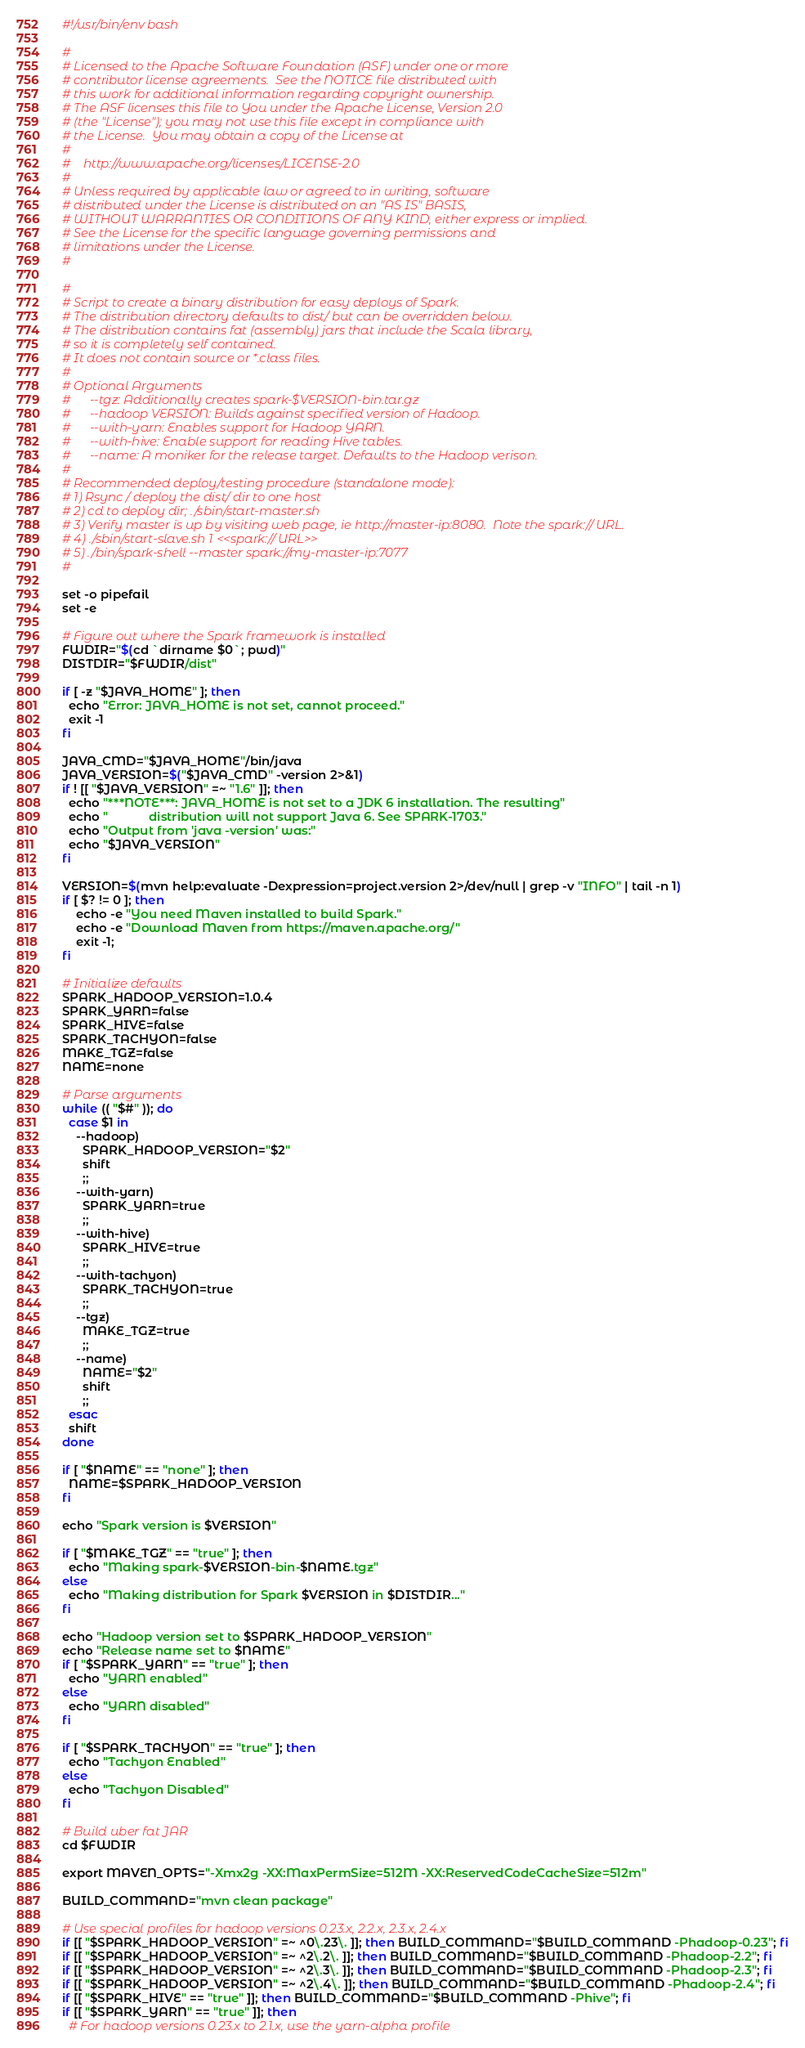<code> <loc_0><loc_0><loc_500><loc_500><_Bash_>#!/usr/bin/env bash

#
# Licensed to the Apache Software Foundation (ASF) under one or more
# contributor license agreements.  See the NOTICE file distributed with
# this work for additional information regarding copyright ownership.
# The ASF licenses this file to You under the Apache License, Version 2.0
# (the "License"); you may not use this file except in compliance with
# the License.  You may obtain a copy of the License at
#
#    http://www.apache.org/licenses/LICENSE-2.0
#
# Unless required by applicable law or agreed to in writing, software
# distributed under the License is distributed on an "AS IS" BASIS,
# WITHOUT WARRANTIES OR CONDITIONS OF ANY KIND, either express or implied.
# See the License for the specific language governing permissions and
# limitations under the License.
#

#
# Script to create a binary distribution for easy deploys of Spark.
# The distribution directory defaults to dist/ but can be overridden below.
# The distribution contains fat (assembly) jars that include the Scala library,
# so it is completely self contained.
# It does not contain source or *.class files.
#
# Optional Arguments
#      --tgz: Additionally creates spark-$VERSION-bin.tar.gz
#      --hadoop VERSION: Builds against specified version of Hadoop.
#      --with-yarn: Enables support for Hadoop YARN.
#      --with-hive: Enable support for reading Hive tables.
#      --name: A moniker for the release target. Defaults to the Hadoop verison.
#
# Recommended deploy/testing procedure (standalone mode):
# 1) Rsync / deploy the dist/ dir to one host
# 2) cd to deploy dir; ./sbin/start-master.sh
# 3) Verify master is up by visiting web page, ie http://master-ip:8080.  Note the spark:// URL.
# 4) ./sbin/start-slave.sh 1 <<spark:// URL>>
# 5) ./bin/spark-shell --master spark://my-master-ip:7077
#

set -o pipefail
set -e

# Figure out where the Spark framework is installed
FWDIR="$(cd `dirname $0`; pwd)"
DISTDIR="$FWDIR/dist"

if [ -z "$JAVA_HOME" ]; then
  echo "Error: JAVA_HOME is not set, cannot proceed."
  exit -1
fi

JAVA_CMD="$JAVA_HOME"/bin/java
JAVA_VERSION=$("$JAVA_CMD" -version 2>&1)
if ! [[ "$JAVA_VERSION" =~ "1.6" ]]; then
  echo "***NOTE***: JAVA_HOME is not set to a JDK 6 installation. The resulting"
  echo "            distribution will not support Java 6. See SPARK-1703."
  echo "Output from 'java -version' was:"
  echo "$JAVA_VERSION"
fi

VERSION=$(mvn help:evaluate -Dexpression=project.version 2>/dev/null | grep -v "INFO" | tail -n 1)
if [ $? != 0 ]; then
    echo -e "You need Maven installed to build Spark."
    echo -e "Download Maven from https://maven.apache.org/"
    exit -1;
fi

# Initialize defaults
SPARK_HADOOP_VERSION=1.0.4
SPARK_YARN=false
SPARK_HIVE=false
SPARK_TACHYON=false
MAKE_TGZ=false
NAME=none

# Parse arguments
while (( "$#" )); do
  case $1 in
    --hadoop)
      SPARK_HADOOP_VERSION="$2"
      shift
      ;;
    --with-yarn)
      SPARK_YARN=true
      ;;
    --with-hive)
      SPARK_HIVE=true
      ;;
    --with-tachyon)
      SPARK_TACHYON=true
      ;;
    --tgz)
      MAKE_TGZ=true
      ;;
    --name)
      NAME="$2"
      shift
      ;;
  esac
  shift
done

if [ "$NAME" == "none" ]; then
  NAME=$SPARK_HADOOP_VERSION
fi

echo "Spark version is $VERSION"

if [ "$MAKE_TGZ" == "true" ]; then
  echo "Making spark-$VERSION-bin-$NAME.tgz"
else
  echo "Making distribution for Spark $VERSION in $DISTDIR..."
fi

echo "Hadoop version set to $SPARK_HADOOP_VERSION"
echo "Release name set to $NAME"
if [ "$SPARK_YARN" == "true" ]; then
  echo "YARN enabled"
else
  echo "YARN disabled"
fi

if [ "$SPARK_TACHYON" == "true" ]; then
  echo "Tachyon Enabled"
else
  echo "Tachyon Disabled"
fi

# Build uber fat JAR
cd $FWDIR

export MAVEN_OPTS="-Xmx2g -XX:MaxPermSize=512M -XX:ReservedCodeCacheSize=512m"

BUILD_COMMAND="mvn clean package"

# Use special profiles for hadoop versions 0.23.x, 2.2.x, 2.3.x, 2.4.x
if [[ "$SPARK_HADOOP_VERSION" =~ ^0\.23\. ]]; then BUILD_COMMAND="$BUILD_COMMAND -Phadoop-0.23"; fi
if [[ "$SPARK_HADOOP_VERSION" =~ ^2\.2\. ]]; then BUILD_COMMAND="$BUILD_COMMAND -Phadoop-2.2"; fi
if [[ "$SPARK_HADOOP_VERSION" =~ ^2\.3\. ]]; then BUILD_COMMAND="$BUILD_COMMAND -Phadoop-2.3"; fi
if [[ "$SPARK_HADOOP_VERSION" =~ ^2\.4\. ]]; then BUILD_COMMAND="$BUILD_COMMAND -Phadoop-2.4"; fi
if [[ "$SPARK_HIVE" == "true" ]]; then BUILD_COMMAND="$BUILD_COMMAND -Phive"; fi
if [[ "$SPARK_YARN" == "true" ]]; then
  # For hadoop versions 0.23.x to 2.1.x, use the yarn-alpha profile</code> 